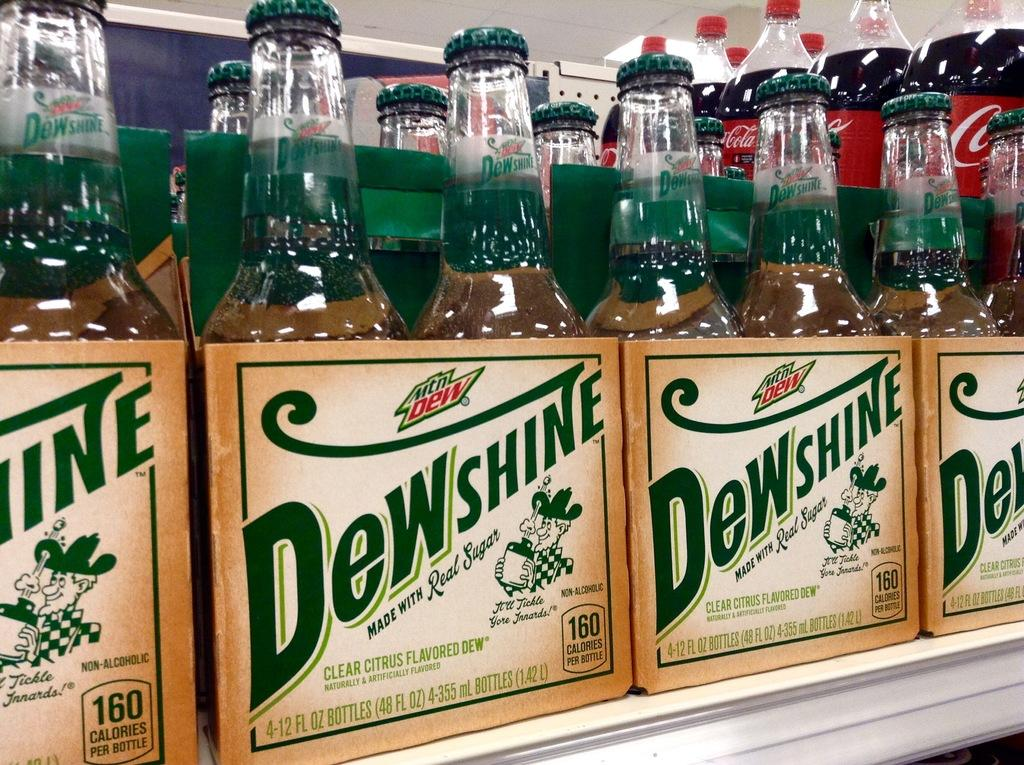What type of beverages can be seen in the image? There are drinks in the image. How are the drinks arranged or stored? The drinks are placed in boxes. What can be seen in the background of the image? There is a wall in the background of the image. What type of cloud can be seen in the image? There is no cloud present in the image. How are the drinks measured in the image? The provided facts do not mention any measurements of the drinks. 